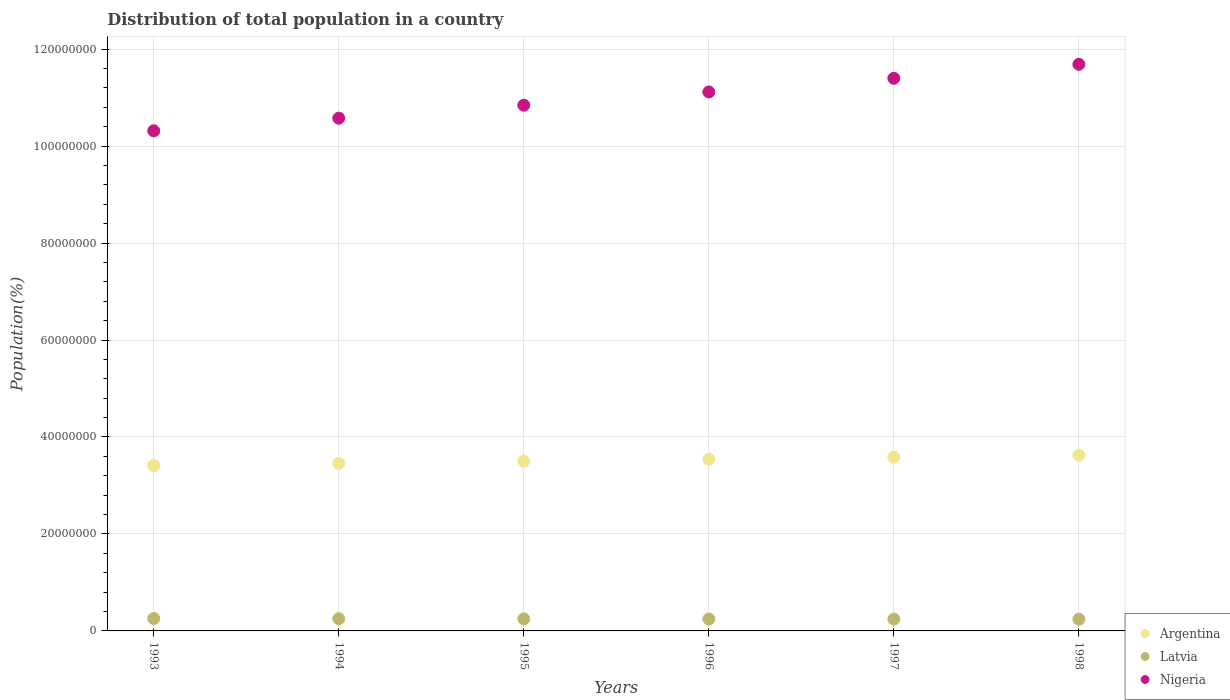How many different coloured dotlines are there?
Ensure brevity in your answer.  3. What is the population of in Latvia in 1994?
Make the answer very short. 2.52e+06. Across all years, what is the maximum population of in Latvia?
Keep it short and to the point. 2.56e+06. Across all years, what is the minimum population of in Argentina?
Provide a short and direct response. 3.41e+07. In which year was the population of in Argentina maximum?
Keep it short and to the point. 1998. In which year was the population of in Latvia minimum?
Ensure brevity in your answer.  1998. What is the total population of in Argentina in the graph?
Keep it short and to the point. 2.11e+08. What is the difference between the population of in Argentina in 1993 and that in 1996?
Provide a succinct answer. -1.31e+06. What is the difference between the population of in Argentina in 1998 and the population of in Latvia in 1996?
Keep it short and to the point. 3.38e+07. What is the average population of in Latvia per year?
Keep it short and to the point. 2.48e+06. In the year 1995, what is the difference between the population of in Argentina and population of in Nigeria?
Your answer should be compact. -7.34e+07. What is the ratio of the population of in Argentina in 1996 to that in 1997?
Ensure brevity in your answer.  0.99. Is the population of in Argentina in 1993 less than that in 1996?
Provide a short and direct response. Yes. Is the difference between the population of in Argentina in 1994 and 1996 greater than the difference between the population of in Nigeria in 1994 and 1996?
Offer a very short reply. Yes. What is the difference between the highest and the second highest population of in Nigeria?
Ensure brevity in your answer.  2.89e+06. What is the difference between the highest and the lowest population of in Latvia?
Your response must be concise. 1.53e+05. Is it the case that in every year, the sum of the population of in Latvia and population of in Nigeria  is greater than the population of in Argentina?
Your answer should be compact. Yes. What is the difference between two consecutive major ticks on the Y-axis?
Your response must be concise. 2.00e+07. Are the values on the major ticks of Y-axis written in scientific E-notation?
Provide a succinct answer. No. Does the graph contain any zero values?
Your answer should be very brief. No. Does the graph contain grids?
Your response must be concise. Yes. Where does the legend appear in the graph?
Offer a terse response. Bottom right. What is the title of the graph?
Give a very brief answer. Distribution of total population in a country. What is the label or title of the Y-axis?
Keep it short and to the point. Population(%). What is the Population(%) in Argentina in 1993?
Your answer should be very brief. 3.41e+07. What is the Population(%) of Latvia in 1993?
Provide a succinct answer. 2.56e+06. What is the Population(%) in Nigeria in 1993?
Provide a short and direct response. 1.03e+08. What is the Population(%) of Argentina in 1994?
Make the answer very short. 3.46e+07. What is the Population(%) in Latvia in 1994?
Your response must be concise. 2.52e+06. What is the Population(%) in Nigeria in 1994?
Ensure brevity in your answer.  1.06e+08. What is the Population(%) in Argentina in 1995?
Your answer should be very brief. 3.50e+07. What is the Population(%) in Latvia in 1995?
Make the answer very short. 2.49e+06. What is the Population(%) of Nigeria in 1995?
Make the answer very short. 1.08e+08. What is the Population(%) of Argentina in 1996?
Provide a succinct answer. 3.54e+07. What is the Population(%) in Latvia in 1996?
Provide a short and direct response. 2.46e+06. What is the Population(%) of Nigeria in 1996?
Offer a terse response. 1.11e+08. What is the Population(%) in Argentina in 1997?
Make the answer very short. 3.58e+07. What is the Population(%) of Latvia in 1997?
Provide a succinct answer. 2.43e+06. What is the Population(%) in Nigeria in 1997?
Your answer should be very brief. 1.14e+08. What is the Population(%) in Argentina in 1998?
Give a very brief answer. 3.62e+07. What is the Population(%) of Latvia in 1998?
Your answer should be compact. 2.41e+06. What is the Population(%) in Nigeria in 1998?
Give a very brief answer. 1.17e+08. Across all years, what is the maximum Population(%) in Argentina?
Give a very brief answer. 3.62e+07. Across all years, what is the maximum Population(%) of Latvia?
Provide a succinct answer. 2.56e+06. Across all years, what is the maximum Population(%) in Nigeria?
Your response must be concise. 1.17e+08. Across all years, what is the minimum Population(%) of Argentina?
Your response must be concise. 3.41e+07. Across all years, what is the minimum Population(%) of Latvia?
Ensure brevity in your answer.  2.41e+06. Across all years, what is the minimum Population(%) in Nigeria?
Provide a short and direct response. 1.03e+08. What is the total Population(%) of Argentina in the graph?
Give a very brief answer. 2.11e+08. What is the total Population(%) of Latvia in the graph?
Ensure brevity in your answer.  1.49e+07. What is the total Population(%) in Nigeria in the graph?
Your answer should be compact. 6.59e+08. What is the difference between the Population(%) of Argentina in 1993 and that in 1994?
Provide a short and direct response. -4.47e+05. What is the difference between the Population(%) of Latvia in 1993 and that in 1994?
Offer a terse response. 4.25e+04. What is the difference between the Population(%) of Nigeria in 1993 and that in 1994?
Keep it short and to the point. -2.61e+06. What is the difference between the Population(%) in Argentina in 1993 and that in 1995?
Your answer should be compact. -8.84e+05. What is the difference between the Population(%) in Latvia in 1993 and that in 1995?
Keep it short and to the point. 7.82e+04. What is the difference between the Population(%) in Nigeria in 1993 and that in 1995?
Your response must be concise. -5.28e+06. What is the difference between the Population(%) of Argentina in 1993 and that in 1996?
Offer a terse response. -1.31e+06. What is the difference between the Population(%) in Latvia in 1993 and that in 1996?
Provide a succinct answer. 1.06e+05. What is the difference between the Population(%) in Nigeria in 1993 and that in 1996?
Your answer should be very brief. -8.02e+06. What is the difference between the Population(%) of Argentina in 1993 and that in 1997?
Your answer should be compact. -1.72e+06. What is the difference between the Population(%) in Latvia in 1993 and that in 1997?
Keep it short and to the point. 1.30e+05. What is the difference between the Population(%) in Nigeria in 1993 and that in 1997?
Offer a very short reply. -1.08e+07. What is the difference between the Population(%) in Argentina in 1993 and that in 1998?
Give a very brief answer. -2.13e+06. What is the difference between the Population(%) of Latvia in 1993 and that in 1998?
Give a very brief answer. 1.53e+05. What is the difference between the Population(%) in Nigeria in 1993 and that in 1998?
Offer a very short reply. -1.37e+07. What is the difference between the Population(%) of Argentina in 1994 and that in 1995?
Make the answer very short. -4.37e+05. What is the difference between the Population(%) in Latvia in 1994 and that in 1995?
Your answer should be very brief. 3.57e+04. What is the difference between the Population(%) in Nigeria in 1994 and that in 1995?
Your answer should be very brief. -2.67e+06. What is the difference between the Population(%) of Argentina in 1994 and that in 1996?
Your answer should be very brief. -8.62e+05. What is the difference between the Population(%) in Latvia in 1994 and that in 1996?
Ensure brevity in your answer.  6.35e+04. What is the difference between the Population(%) of Nigeria in 1994 and that in 1996?
Offer a very short reply. -5.41e+06. What is the difference between the Population(%) in Argentina in 1994 and that in 1997?
Your answer should be very brief. -1.28e+06. What is the difference between the Population(%) in Latvia in 1994 and that in 1997?
Provide a short and direct response. 8.79e+04. What is the difference between the Population(%) in Nigeria in 1994 and that in 1997?
Offer a terse response. -8.22e+06. What is the difference between the Population(%) of Argentina in 1994 and that in 1998?
Keep it short and to the point. -1.68e+06. What is the difference between the Population(%) of Latvia in 1994 and that in 1998?
Your answer should be very brief. 1.11e+05. What is the difference between the Population(%) of Nigeria in 1994 and that in 1998?
Your response must be concise. -1.11e+07. What is the difference between the Population(%) of Argentina in 1995 and that in 1996?
Offer a very short reply. -4.25e+05. What is the difference between the Population(%) of Latvia in 1995 and that in 1996?
Give a very brief answer. 2.78e+04. What is the difference between the Population(%) in Nigeria in 1995 and that in 1996?
Make the answer very short. -2.74e+06. What is the difference between the Population(%) of Argentina in 1995 and that in 1997?
Ensure brevity in your answer.  -8.39e+05. What is the difference between the Population(%) in Latvia in 1995 and that in 1997?
Keep it short and to the point. 5.22e+04. What is the difference between the Population(%) of Nigeria in 1995 and that in 1997?
Provide a succinct answer. -5.55e+06. What is the difference between the Population(%) in Argentina in 1995 and that in 1998?
Your answer should be compact. -1.25e+06. What is the difference between the Population(%) in Latvia in 1995 and that in 1998?
Offer a very short reply. 7.50e+04. What is the difference between the Population(%) of Nigeria in 1995 and that in 1998?
Make the answer very short. -8.44e+06. What is the difference between the Population(%) in Argentina in 1996 and that in 1997?
Provide a succinct answer. -4.14e+05. What is the difference between the Population(%) in Latvia in 1996 and that in 1997?
Give a very brief answer. 2.44e+04. What is the difference between the Population(%) of Nigeria in 1996 and that in 1997?
Ensure brevity in your answer.  -2.81e+06. What is the difference between the Population(%) of Argentina in 1996 and that in 1998?
Offer a very short reply. -8.22e+05. What is the difference between the Population(%) in Latvia in 1996 and that in 1998?
Keep it short and to the point. 4.72e+04. What is the difference between the Population(%) of Nigeria in 1996 and that in 1998?
Your response must be concise. -5.70e+06. What is the difference between the Population(%) of Argentina in 1997 and that in 1998?
Keep it short and to the point. -4.08e+05. What is the difference between the Population(%) in Latvia in 1997 and that in 1998?
Keep it short and to the point. 2.28e+04. What is the difference between the Population(%) in Nigeria in 1997 and that in 1998?
Offer a very short reply. -2.89e+06. What is the difference between the Population(%) in Argentina in 1993 and the Population(%) in Latvia in 1994?
Make the answer very short. 3.16e+07. What is the difference between the Population(%) in Argentina in 1993 and the Population(%) in Nigeria in 1994?
Keep it short and to the point. -7.16e+07. What is the difference between the Population(%) of Latvia in 1993 and the Population(%) of Nigeria in 1994?
Keep it short and to the point. -1.03e+08. What is the difference between the Population(%) in Argentina in 1993 and the Population(%) in Latvia in 1995?
Ensure brevity in your answer.  3.16e+07. What is the difference between the Population(%) of Argentina in 1993 and the Population(%) of Nigeria in 1995?
Provide a short and direct response. -7.43e+07. What is the difference between the Population(%) in Latvia in 1993 and the Population(%) in Nigeria in 1995?
Provide a short and direct response. -1.06e+08. What is the difference between the Population(%) of Argentina in 1993 and the Population(%) of Latvia in 1996?
Keep it short and to the point. 3.17e+07. What is the difference between the Population(%) in Argentina in 1993 and the Population(%) in Nigeria in 1996?
Provide a succinct answer. -7.71e+07. What is the difference between the Population(%) in Latvia in 1993 and the Population(%) in Nigeria in 1996?
Your answer should be compact. -1.09e+08. What is the difference between the Population(%) in Argentina in 1993 and the Population(%) in Latvia in 1997?
Ensure brevity in your answer.  3.17e+07. What is the difference between the Population(%) of Argentina in 1993 and the Population(%) of Nigeria in 1997?
Provide a short and direct response. -7.99e+07. What is the difference between the Population(%) of Latvia in 1993 and the Population(%) of Nigeria in 1997?
Provide a short and direct response. -1.11e+08. What is the difference between the Population(%) of Argentina in 1993 and the Population(%) of Latvia in 1998?
Give a very brief answer. 3.17e+07. What is the difference between the Population(%) in Argentina in 1993 and the Population(%) in Nigeria in 1998?
Your response must be concise. -8.27e+07. What is the difference between the Population(%) of Latvia in 1993 and the Population(%) of Nigeria in 1998?
Provide a succinct answer. -1.14e+08. What is the difference between the Population(%) in Argentina in 1994 and the Population(%) in Latvia in 1995?
Give a very brief answer. 3.21e+07. What is the difference between the Population(%) in Argentina in 1994 and the Population(%) in Nigeria in 1995?
Offer a very short reply. -7.39e+07. What is the difference between the Population(%) of Latvia in 1994 and the Population(%) of Nigeria in 1995?
Keep it short and to the point. -1.06e+08. What is the difference between the Population(%) in Argentina in 1994 and the Population(%) in Latvia in 1996?
Your response must be concise. 3.21e+07. What is the difference between the Population(%) in Argentina in 1994 and the Population(%) in Nigeria in 1996?
Your response must be concise. -7.66e+07. What is the difference between the Population(%) of Latvia in 1994 and the Population(%) of Nigeria in 1996?
Your answer should be very brief. -1.09e+08. What is the difference between the Population(%) of Argentina in 1994 and the Population(%) of Latvia in 1997?
Your answer should be compact. 3.21e+07. What is the difference between the Population(%) in Argentina in 1994 and the Population(%) in Nigeria in 1997?
Offer a terse response. -7.94e+07. What is the difference between the Population(%) in Latvia in 1994 and the Population(%) in Nigeria in 1997?
Keep it short and to the point. -1.11e+08. What is the difference between the Population(%) of Argentina in 1994 and the Population(%) of Latvia in 1998?
Your answer should be very brief. 3.21e+07. What is the difference between the Population(%) in Argentina in 1994 and the Population(%) in Nigeria in 1998?
Your answer should be very brief. -8.23e+07. What is the difference between the Population(%) in Latvia in 1994 and the Population(%) in Nigeria in 1998?
Offer a terse response. -1.14e+08. What is the difference between the Population(%) in Argentina in 1995 and the Population(%) in Latvia in 1996?
Ensure brevity in your answer.  3.25e+07. What is the difference between the Population(%) in Argentina in 1995 and the Population(%) in Nigeria in 1996?
Make the answer very short. -7.62e+07. What is the difference between the Population(%) in Latvia in 1995 and the Population(%) in Nigeria in 1996?
Ensure brevity in your answer.  -1.09e+08. What is the difference between the Population(%) of Argentina in 1995 and the Population(%) of Latvia in 1997?
Your response must be concise. 3.26e+07. What is the difference between the Population(%) in Argentina in 1995 and the Population(%) in Nigeria in 1997?
Provide a short and direct response. -7.90e+07. What is the difference between the Population(%) of Latvia in 1995 and the Population(%) of Nigeria in 1997?
Your answer should be compact. -1.11e+08. What is the difference between the Population(%) of Argentina in 1995 and the Population(%) of Latvia in 1998?
Make the answer very short. 3.26e+07. What is the difference between the Population(%) in Argentina in 1995 and the Population(%) in Nigeria in 1998?
Ensure brevity in your answer.  -8.19e+07. What is the difference between the Population(%) of Latvia in 1995 and the Population(%) of Nigeria in 1998?
Give a very brief answer. -1.14e+08. What is the difference between the Population(%) of Argentina in 1996 and the Population(%) of Latvia in 1997?
Make the answer very short. 3.30e+07. What is the difference between the Population(%) of Argentina in 1996 and the Population(%) of Nigeria in 1997?
Provide a short and direct response. -7.86e+07. What is the difference between the Population(%) in Latvia in 1996 and the Population(%) in Nigeria in 1997?
Keep it short and to the point. -1.12e+08. What is the difference between the Population(%) in Argentina in 1996 and the Population(%) in Latvia in 1998?
Your answer should be compact. 3.30e+07. What is the difference between the Population(%) in Argentina in 1996 and the Population(%) in Nigeria in 1998?
Make the answer very short. -8.14e+07. What is the difference between the Population(%) in Latvia in 1996 and the Population(%) in Nigeria in 1998?
Make the answer very short. -1.14e+08. What is the difference between the Population(%) of Argentina in 1997 and the Population(%) of Latvia in 1998?
Offer a very short reply. 3.34e+07. What is the difference between the Population(%) of Argentina in 1997 and the Population(%) of Nigeria in 1998?
Ensure brevity in your answer.  -8.10e+07. What is the difference between the Population(%) in Latvia in 1997 and the Population(%) in Nigeria in 1998?
Offer a terse response. -1.14e+08. What is the average Population(%) in Argentina per year?
Ensure brevity in your answer.  3.52e+07. What is the average Population(%) in Latvia per year?
Offer a terse response. 2.48e+06. What is the average Population(%) in Nigeria per year?
Offer a very short reply. 1.10e+08. In the year 1993, what is the difference between the Population(%) in Argentina and Population(%) in Latvia?
Your answer should be compact. 3.15e+07. In the year 1993, what is the difference between the Population(%) of Argentina and Population(%) of Nigeria?
Keep it short and to the point. -6.90e+07. In the year 1993, what is the difference between the Population(%) of Latvia and Population(%) of Nigeria?
Your answer should be very brief. -1.01e+08. In the year 1994, what is the difference between the Population(%) of Argentina and Population(%) of Latvia?
Provide a short and direct response. 3.20e+07. In the year 1994, what is the difference between the Population(%) in Argentina and Population(%) in Nigeria?
Provide a short and direct response. -7.12e+07. In the year 1994, what is the difference between the Population(%) of Latvia and Population(%) of Nigeria?
Give a very brief answer. -1.03e+08. In the year 1995, what is the difference between the Population(%) of Argentina and Population(%) of Latvia?
Your response must be concise. 3.25e+07. In the year 1995, what is the difference between the Population(%) of Argentina and Population(%) of Nigeria?
Make the answer very short. -7.34e+07. In the year 1995, what is the difference between the Population(%) in Latvia and Population(%) in Nigeria?
Provide a short and direct response. -1.06e+08. In the year 1996, what is the difference between the Population(%) in Argentina and Population(%) in Latvia?
Your response must be concise. 3.30e+07. In the year 1996, what is the difference between the Population(%) in Argentina and Population(%) in Nigeria?
Ensure brevity in your answer.  -7.57e+07. In the year 1996, what is the difference between the Population(%) in Latvia and Population(%) in Nigeria?
Ensure brevity in your answer.  -1.09e+08. In the year 1997, what is the difference between the Population(%) of Argentina and Population(%) of Latvia?
Your response must be concise. 3.34e+07. In the year 1997, what is the difference between the Population(%) of Argentina and Population(%) of Nigeria?
Your answer should be compact. -7.81e+07. In the year 1997, what is the difference between the Population(%) of Latvia and Population(%) of Nigeria?
Make the answer very short. -1.12e+08. In the year 1998, what is the difference between the Population(%) in Argentina and Population(%) in Latvia?
Offer a terse response. 3.38e+07. In the year 1998, what is the difference between the Population(%) of Argentina and Population(%) of Nigeria?
Give a very brief answer. -8.06e+07. In the year 1998, what is the difference between the Population(%) in Latvia and Population(%) in Nigeria?
Provide a succinct answer. -1.14e+08. What is the ratio of the Population(%) in Argentina in 1993 to that in 1994?
Ensure brevity in your answer.  0.99. What is the ratio of the Population(%) in Latvia in 1993 to that in 1994?
Make the answer very short. 1.02. What is the ratio of the Population(%) in Nigeria in 1993 to that in 1994?
Give a very brief answer. 0.98. What is the ratio of the Population(%) in Argentina in 1993 to that in 1995?
Your response must be concise. 0.97. What is the ratio of the Population(%) in Latvia in 1993 to that in 1995?
Give a very brief answer. 1.03. What is the ratio of the Population(%) in Nigeria in 1993 to that in 1995?
Provide a short and direct response. 0.95. What is the ratio of the Population(%) in Latvia in 1993 to that in 1996?
Ensure brevity in your answer.  1.04. What is the ratio of the Population(%) of Nigeria in 1993 to that in 1996?
Offer a terse response. 0.93. What is the ratio of the Population(%) of Argentina in 1993 to that in 1997?
Ensure brevity in your answer.  0.95. What is the ratio of the Population(%) in Latvia in 1993 to that in 1997?
Your answer should be compact. 1.05. What is the ratio of the Population(%) in Nigeria in 1993 to that in 1997?
Offer a very short reply. 0.91. What is the ratio of the Population(%) of Latvia in 1993 to that in 1998?
Provide a short and direct response. 1.06. What is the ratio of the Population(%) in Nigeria in 1993 to that in 1998?
Offer a very short reply. 0.88. What is the ratio of the Population(%) of Argentina in 1994 to that in 1995?
Ensure brevity in your answer.  0.99. What is the ratio of the Population(%) of Latvia in 1994 to that in 1995?
Ensure brevity in your answer.  1.01. What is the ratio of the Population(%) of Nigeria in 1994 to that in 1995?
Provide a succinct answer. 0.98. What is the ratio of the Population(%) of Argentina in 1994 to that in 1996?
Your answer should be compact. 0.98. What is the ratio of the Population(%) in Latvia in 1994 to that in 1996?
Your answer should be very brief. 1.03. What is the ratio of the Population(%) in Nigeria in 1994 to that in 1996?
Make the answer very short. 0.95. What is the ratio of the Population(%) in Argentina in 1994 to that in 1997?
Offer a very short reply. 0.96. What is the ratio of the Population(%) in Latvia in 1994 to that in 1997?
Give a very brief answer. 1.04. What is the ratio of the Population(%) of Nigeria in 1994 to that in 1997?
Your answer should be compact. 0.93. What is the ratio of the Population(%) in Argentina in 1994 to that in 1998?
Ensure brevity in your answer.  0.95. What is the ratio of the Population(%) of Latvia in 1994 to that in 1998?
Provide a short and direct response. 1.05. What is the ratio of the Population(%) of Nigeria in 1994 to that in 1998?
Your answer should be compact. 0.91. What is the ratio of the Population(%) of Argentina in 1995 to that in 1996?
Provide a succinct answer. 0.99. What is the ratio of the Population(%) of Latvia in 1995 to that in 1996?
Provide a short and direct response. 1.01. What is the ratio of the Population(%) of Nigeria in 1995 to that in 1996?
Your response must be concise. 0.98. What is the ratio of the Population(%) in Argentina in 1995 to that in 1997?
Your answer should be very brief. 0.98. What is the ratio of the Population(%) of Latvia in 1995 to that in 1997?
Your answer should be compact. 1.02. What is the ratio of the Population(%) of Nigeria in 1995 to that in 1997?
Your answer should be very brief. 0.95. What is the ratio of the Population(%) of Argentina in 1995 to that in 1998?
Offer a terse response. 0.97. What is the ratio of the Population(%) in Latvia in 1995 to that in 1998?
Provide a succinct answer. 1.03. What is the ratio of the Population(%) of Nigeria in 1995 to that in 1998?
Your response must be concise. 0.93. What is the ratio of the Population(%) in Argentina in 1996 to that in 1997?
Offer a terse response. 0.99. What is the ratio of the Population(%) in Latvia in 1996 to that in 1997?
Your response must be concise. 1.01. What is the ratio of the Population(%) in Nigeria in 1996 to that in 1997?
Give a very brief answer. 0.98. What is the ratio of the Population(%) of Argentina in 1996 to that in 1998?
Your answer should be compact. 0.98. What is the ratio of the Population(%) of Latvia in 1996 to that in 1998?
Offer a very short reply. 1.02. What is the ratio of the Population(%) of Nigeria in 1996 to that in 1998?
Ensure brevity in your answer.  0.95. What is the ratio of the Population(%) of Latvia in 1997 to that in 1998?
Your answer should be very brief. 1.01. What is the ratio of the Population(%) in Nigeria in 1997 to that in 1998?
Offer a terse response. 0.98. What is the difference between the highest and the second highest Population(%) in Argentina?
Your answer should be compact. 4.08e+05. What is the difference between the highest and the second highest Population(%) in Latvia?
Keep it short and to the point. 4.25e+04. What is the difference between the highest and the second highest Population(%) in Nigeria?
Your answer should be very brief. 2.89e+06. What is the difference between the highest and the lowest Population(%) in Argentina?
Make the answer very short. 2.13e+06. What is the difference between the highest and the lowest Population(%) in Latvia?
Keep it short and to the point. 1.53e+05. What is the difference between the highest and the lowest Population(%) in Nigeria?
Provide a succinct answer. 1.37e+07. 